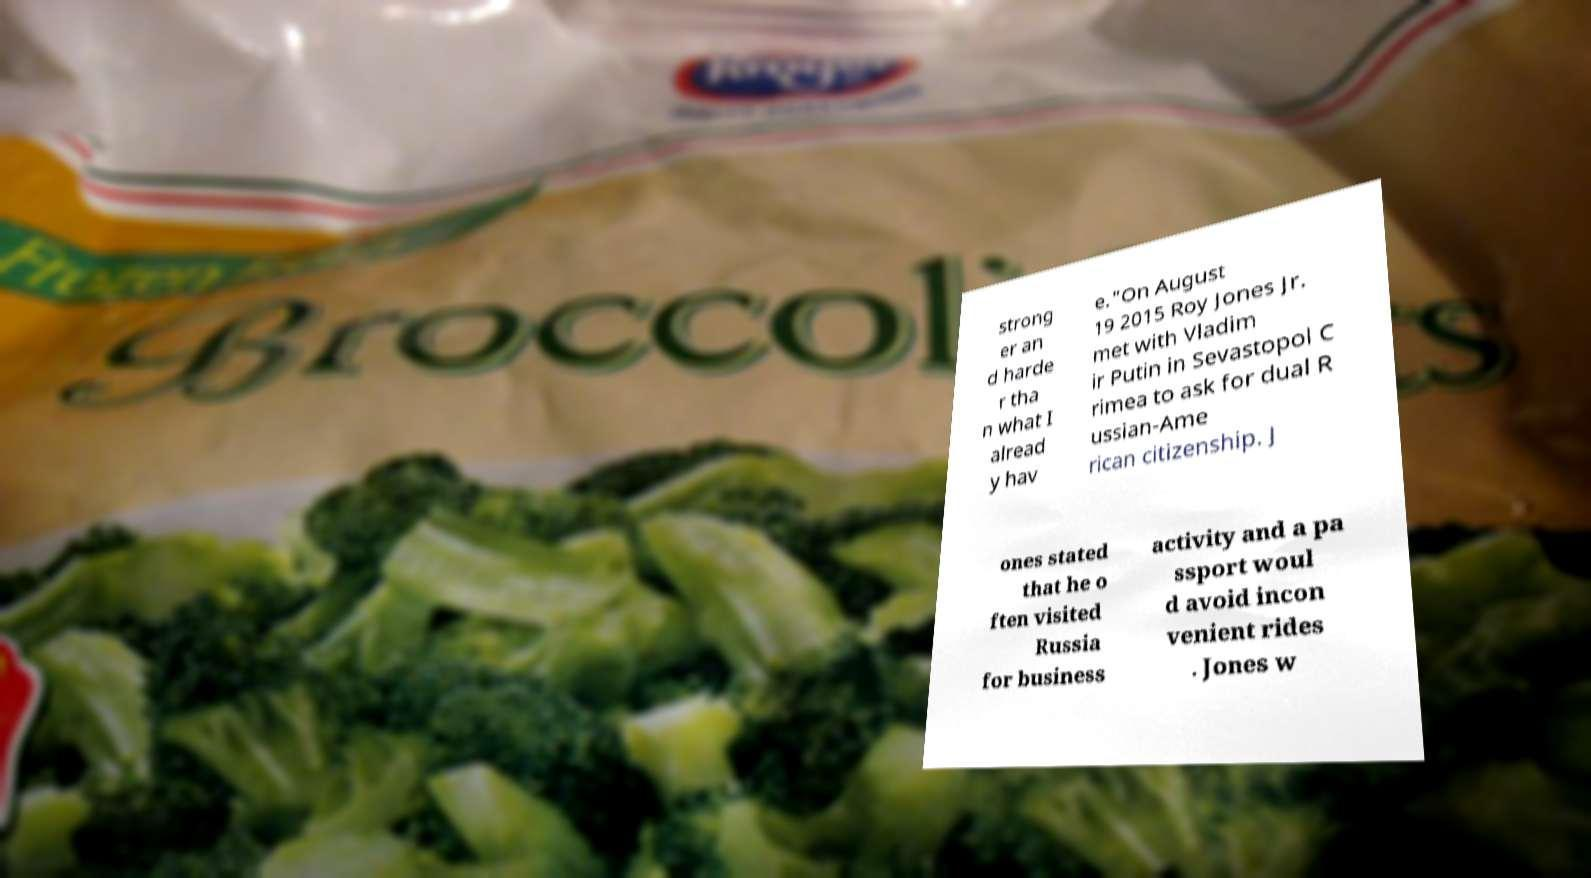I need the written content from this picture converted into text. Can you do that? strong er an d harde r tha n what I alread y hav e."On August 19 2015 Roy Jones Jr. met with Vladim ir Putin in Sevastopol C rimea to ask for dual R ussian-Ame rican citizenship. J ones stated that he o ften visited Russia for business activity and a pa ssport woul d avoid incon venient rides . Jones w 